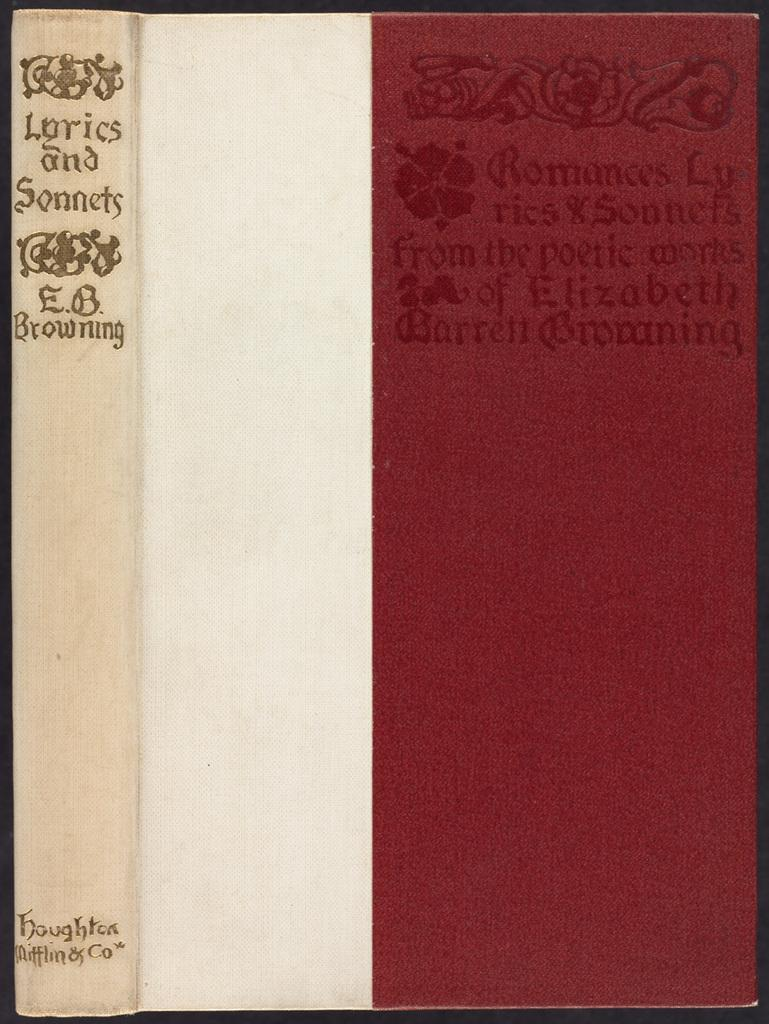<image>
Give a short and clear explanation of the subsequent image. A book by E.B. Browning is titled Lyrics and Sonnets. 